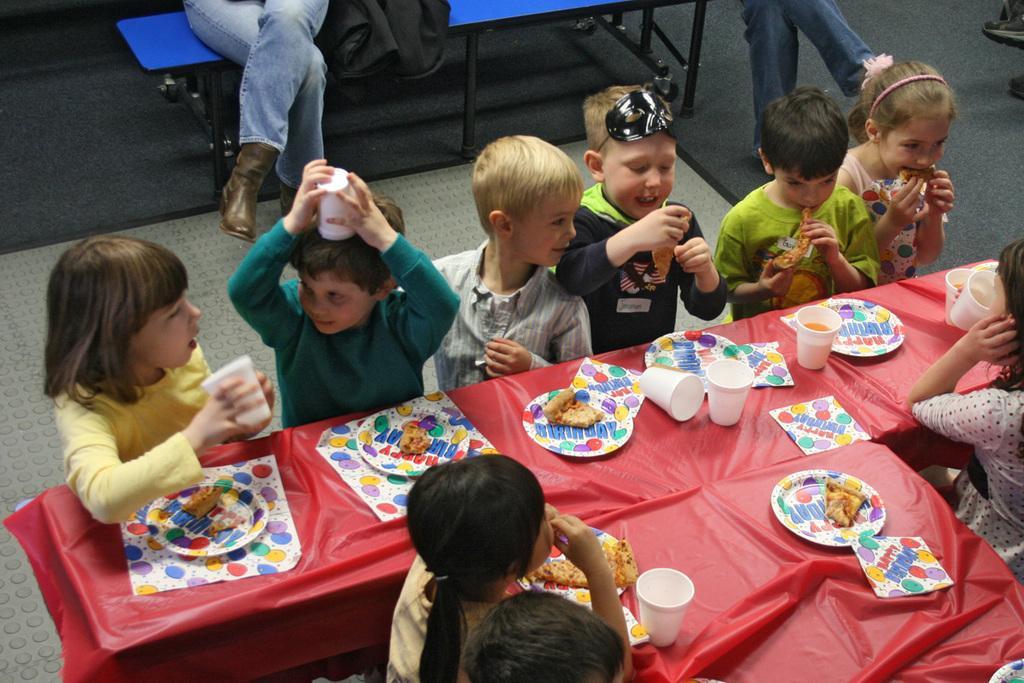In one or two sentences, can you explain what this image depicts? In this image there are 2 girls and 4 boys standing in an order near the table and in table there is a colorful paper and a colorful plate with the food , glasses and in back ground there are table , persons sitting. 